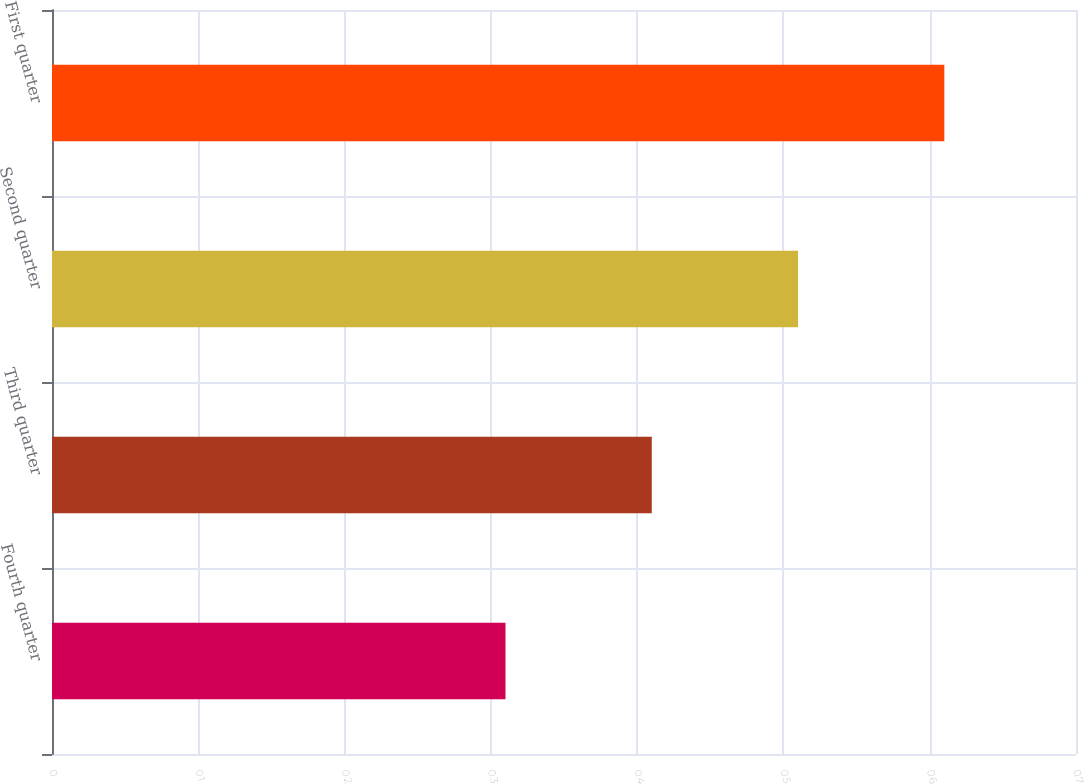<chart> <loc_0><loc_0><loc_500><loc_500><bar_chart><fcel>Fourth quarter<fcel>Third quarter<fcel>Second quarter<fcel>First quarter<nl><fcel>0.31<fcel>0.41<fcel>0.51<fcel>0.61<nl></chart> 